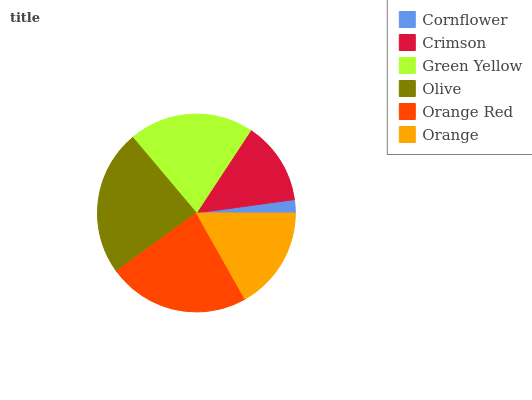Is Cornflower the minimum?
Answer yes or no. Yes. Is Olive the maximum?
Answer yes or no. Yes. Is Crimson the minimum?
Answer yes or no. No. Is Crimson the maximum?
Answer yes or no. No. Is Crimson greater than Cornflower?
Answer yes or no. Yes. Is Cornflower less than Crimson?
Answer yes or no. Yes. Is Cornflower greater than Crimson?
Answer yes or no. No. Is Crimson less than Cornflower?
Answer yes or no. No. Is Green Yellow the high median?
Answer yes or no. Yes. Is Orange the low median?
Answer yes or no. Yes. Is Cornflower the high median?
Answer yes or no. No. Is Cornflower the low median?
Answer yes or no. No. 